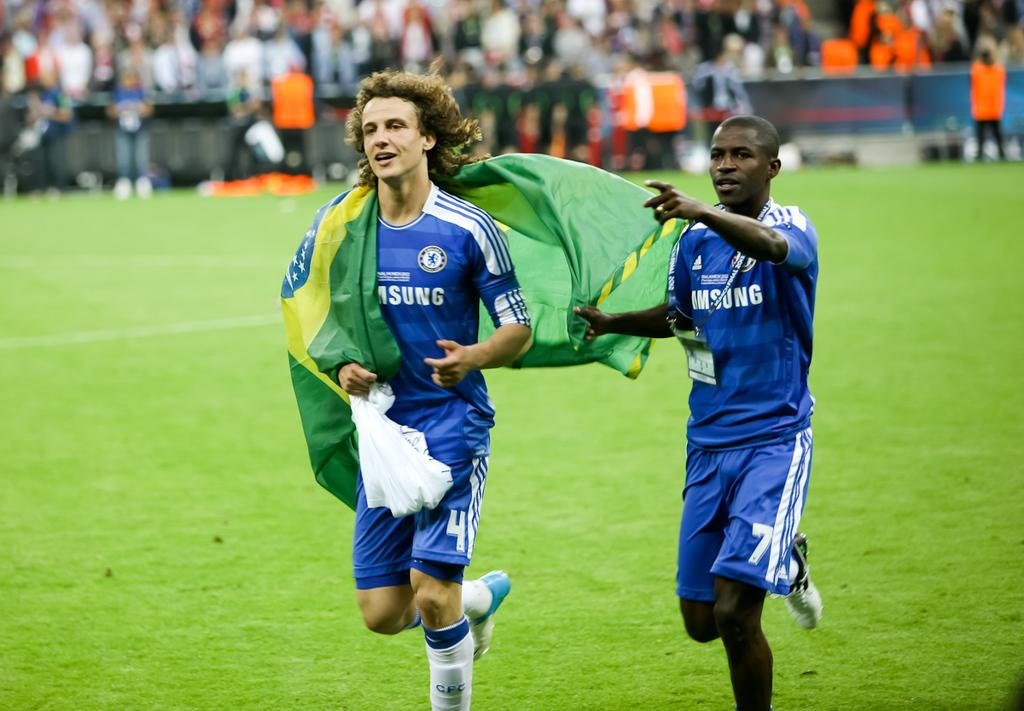<image>
Render a clear and concise summary of the photo. Two players in Blue Samsung jerseys with the Brazilian flag. 